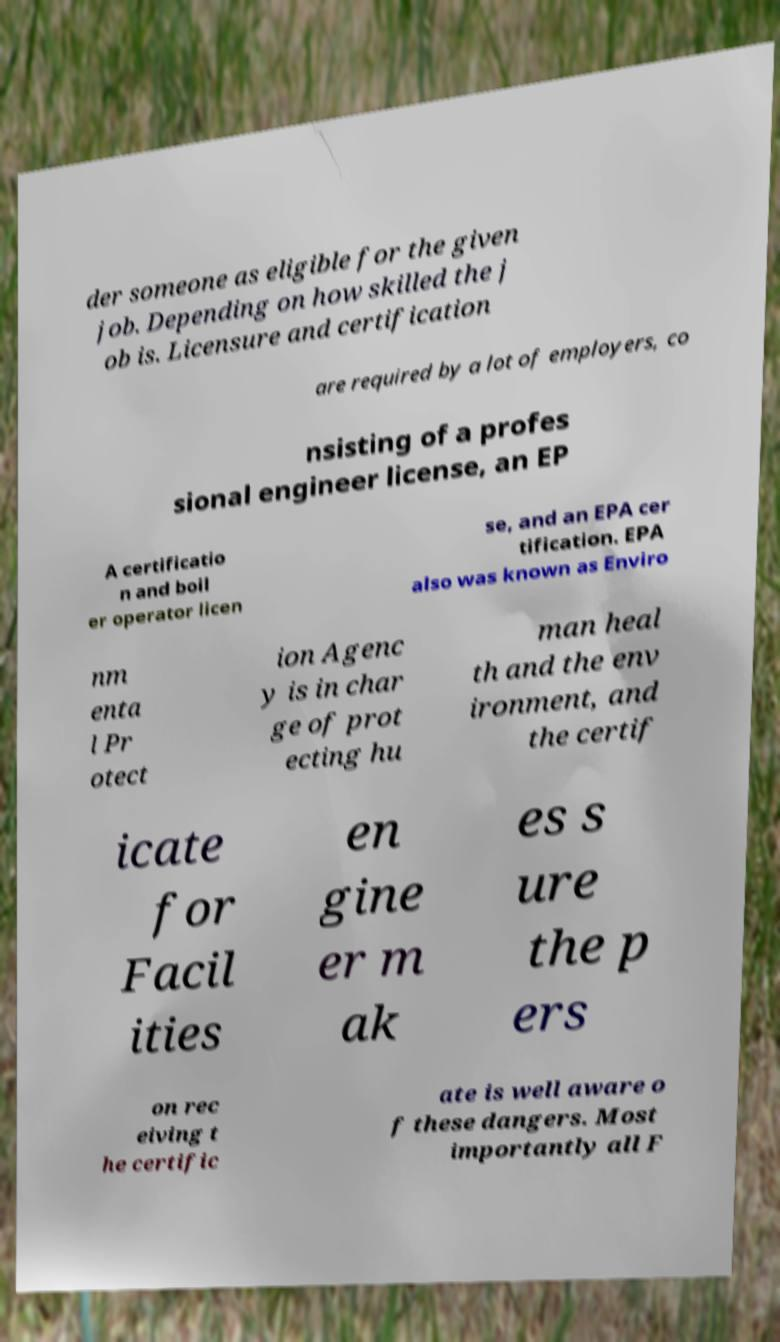Can you read and provide the text displayed in the image?This photo seems to have some interesting text. Can you extract and type it out for me? der someone as eligible for the given job. Depending on how skilled the j ob is. Licensure and certification are required by a lot of employers, co nsisting of a profes sional engineer license, an EP A certificatio n and boil er operator licen se, and an EPA cer tification. EPA also was known as Enviro nm enta l Pr otect ion Agenc y is in char ge of prot ecting hu man heal th and the env ironment, and the certif icate for Facil ities en gine er m ak es s ure the p ers on rec eiving t he certific ate is well aware o f these dangers. Most importantly all F 